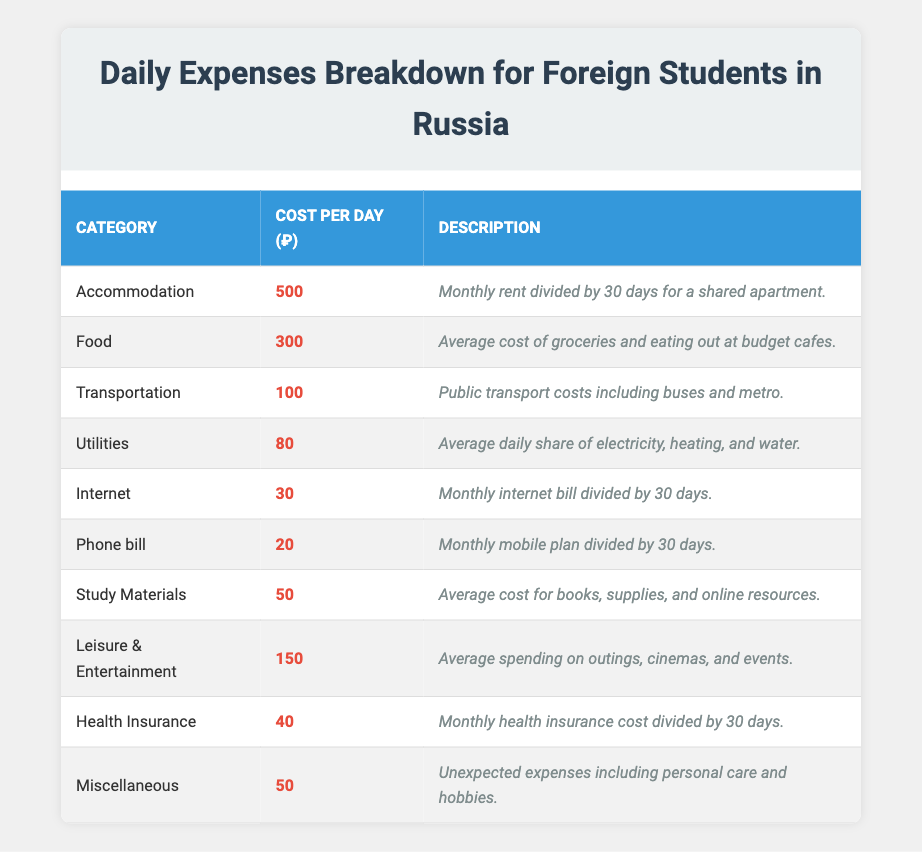What is the highest daily expense category? By examining the "Cost per Day" column, I look for the category with the largest value. The highest value is 500, which corresponds to "Accommodation."
Answer: Accommodation What is the total daily expense for Food and Transportation? I add the cost for "Food" (300) and "Transportation" (100). Thus, the total is 300 + 100 = 400.
Answer: 400 Is the cost of Health Insurance more than the cost of Internet? I compare the values in the respective categories. Health Insurance costs 40, while Internet costs 30. Since 40 is greater than 30, the statement is true.
Answer: Yes What is the average daily expense across all categories? I sum all the daily costs (500 + 300 + 100 + 80 + 30 + 20 + 50 + 150 + 40 + 50 = 1320) and divide by the number of categories (10). Thus, 1320 / 10 = 132.
Answer: 132 What is the difference between the daily cost of Leisure & Entertainment and the daily cost of Study Materials? I subtract the cost of "Study Materials" (50) from "Leisure & Entertainment" (150). Therefore, the difference is 150 - 50 = 100.
Answer: 100 What is the total daily cost of Utilities, Internet, and Phone bill combined? I add the costs of "Utilities" (80), "Internet" (30), and "Phone bill" (20). Hence, the total is 80 + 30 + 20 = 130.
Answer: 130 Which category has the lowest daily cost? Looking through the "Cost per Day" column, I find the lowest value, which is 20 for "Phone bill."
Answer: Phone bill What percentage of the total daily expense is spent on Food? First, I calculate the percentage corresponding to "Food." The total daily expense is 1320, and "Food" cost is 300. So the percentage is (300 / 1320) * 100 ≈ 22.73%.
Answer: 22.73% Are the daily expenses for Accommodation and Miscellaneous greater than 600 combined? I add the costs for both categories (Accommodation: 500 and Miscellaneous: 50). The total is 500 + 50 = 550, which is less than 600.
Answer: No Which three categories consume the most daily expenses, and what is their total? By identifying the three highest categories: Accommodation (500), Food (300), and Leisure & Entertainment (150), I sum these values (500 + 300 + 150 = 950).
Answer: 950 